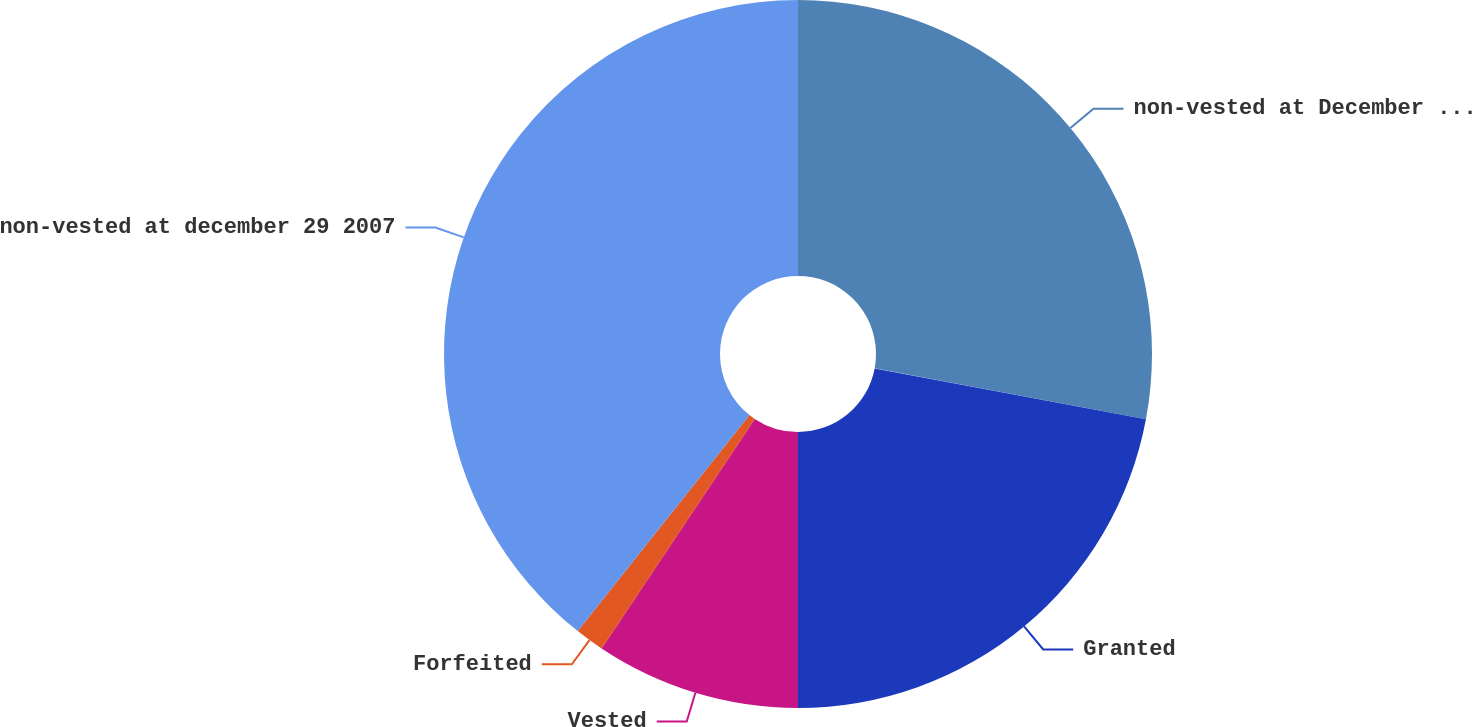<chart> <loc_0><loc_0><loc_500><loc_500><pie_chart><fcel>non-vested at December 30 2006<fcel>Granted<fcel>Vested<fcel>Forfeited<fcel>non-vested at december 29 2007<nl><fcel>27.95%<fcel>22.05%<fcel>9.36%<fcel>1.33%<fcel>39.31%<nl></chart> 